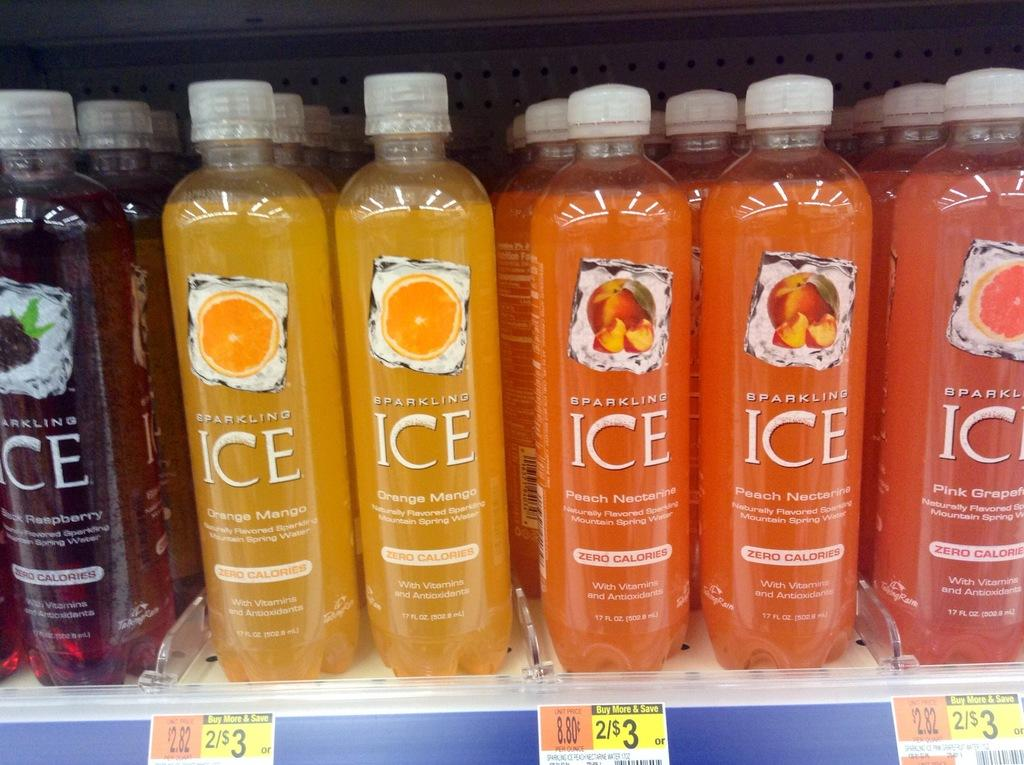<image>
Summarize the visual content of the image. a grocery shelf of colorful Sparkling Ice drinks 